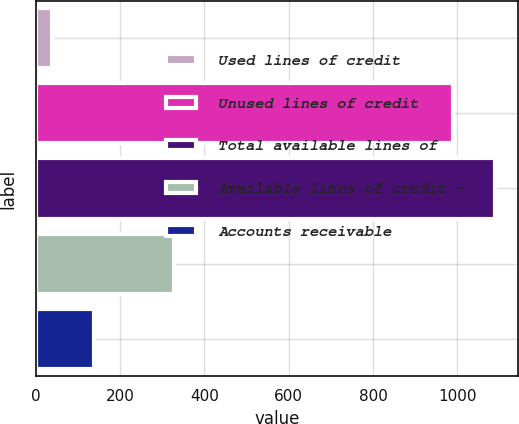Convert chart to OTSL. <chart><loc_0><loc_0><loc_500><loc_500><bar_chart><fcel>Used lines of credit<fcel>Unused lines of credit<fcel>Total available lines of<fcel>Available lines of credit -<fcel>Accounts receivable<nl><fcel>39.2<fcel>989.5<fcel>1088.45<fcel>328.2<fcel>138.15<nl></chart> 